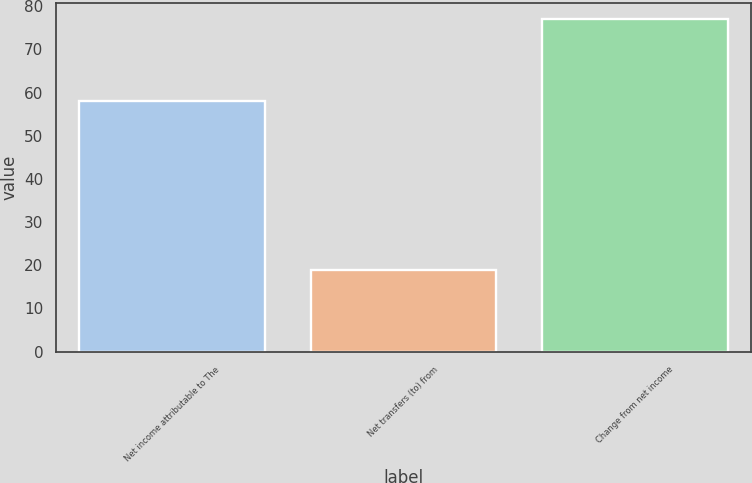<chart> <loc_0><loc_0><loc_500><loc_500><bar_chart><fcel>Net income attributable to The<fcel>Net transfers (to) from<fcel>Change from net income<nl><fcel>58<fcel>19<fcel>77<nl></chart> 